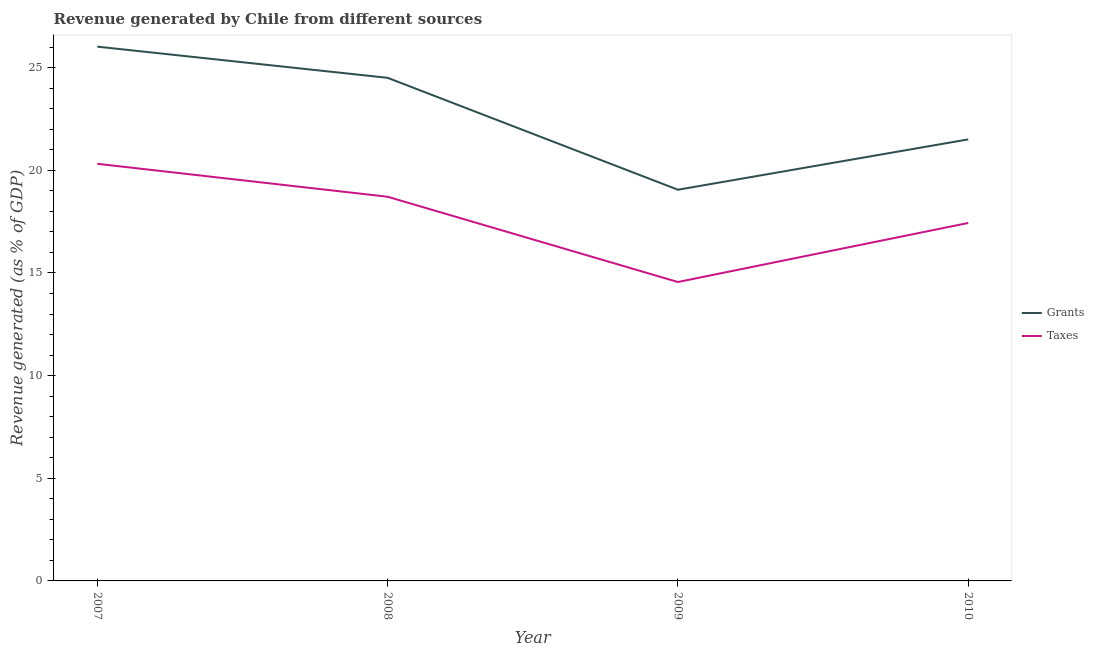Is the number of lines equal to the number of legend labels?
Offer a very short reply. Yes. What is the revenue generated by grants in 2009?
Give a very brief answer. 19.05. Across all years, what is the maximum revenue generated by taxes?
Keep it short and to the point. 20.32. Across all years, what is the minimum revenue generated by taxes?
Your answer should be very brief. 14.56. In which year was the revenue generated by grants maximum?
Your answer should be very brief. 2007. What is the total revenue generated by taxes in the graph?
Your answer should be very brief. 71.03. What is the difference between the revenue generated by grants in 2007 and that in 2008?
Give a very brief answer. 1.52. What is the difference between the revenue generated by taxes in 2010 and the revenue generated by grants in 2008?
Ensure brevity in your answer.  -7.07. What is the average revenue generated by grants per year?
Make the answer very short. 22.77. In the year 2009, what is the difference between the revenue generated by grants and revenue generated by taxes?
Offer a very short reply. 4.5. What is the ratio of the revenue generated by taxes in 2007 to that in 2009?
Give a very brief answer. 1.4. Is the difference between the revenue generated by taxes in 2009 and 2010 greater than the difference between the revenue generated by grants in 2009 and 2010?
Your answer should be very brief. No. What is the difference between the highest and the second highest revenue generated by taxes?
Your answer should be compact. 1.61. What is the difference between the highest and the lowest revenue generated by grants?
Make the answer very short. 6.97. In how many years, is the revenue generated by taxes greater than the average revenue generated by taxes taken over all years?
Give a very brief answer. 2. Is the sum of the revenue generated by taxes in 2007 and 2008 greater than the maximum revenue generated by grants across all years?
Offer a very short reply. Yes. Is the revenue generated by taxes strictly greater than the revenue generated by grants over the years?
Make the answer very short. No. How many lines are there?
Keep it short and to the point. 2. How many years are there in the graph?
Your answer should be compact. 4. What is the difference between two consecutive major ticks on the Y-axis?
Your answer should be very brief. 5. How many legend labels are there?
Give a very brief answer. 2. What is the title of the graph?
Your answer should be compact. Revenue generated by Chile from different sources. What is the label or title of the X-axis?
Provide a succinct answer. Year. What is the label or title of the Y-axis?
Offer a terse response. Revenue generated (as % of GDP). What is the Revenue generated (as % of GDP) in Grants in 2007?
Keep it short and to the point. 26.02. What is the Revenue generated (as % of GDP) of Taxes in 2007?
Provide a succinct answer. 20.32. What is the Revenue generated (as % of GDP) of Grants in 2008?
Offer a very short reply. 24.51. What is the Revenue generated (as % of GDP) of Taxes in 2008?
Provide a short and direct response. 18.71. What is the Revenue generated (as % of GDP) in Grants in 2009?
Your response must be concise. 19.05. What is the Revenue generated (as % of GDP) in Taxes in 2009?
Your answer should be compact. 14.56. What is the Revenue generated (as % of GDP) of Grants in 2010?
Offer a very short reply. 21.51. What is the Revenue generated (as % of GDP) of Taxes in 2010?
Provide a succinct answer. 17.44. Across all years, what is the maximum Revenue generated (as % of GDP) in Grants?
Give a very brief answer. 26.02. Across all years, what is the maximum Revenue generated (as % of GDP) in Taxes?
Your answer should be compact. 20.32. Across all years, what is the minimum Revenue generated (as % of GDP) in Grants?
Your response must be concise. 19.05. Across all years, what is the minimum Revenue generated (as % of GDP) in Taxes?
Provide a succinct answer. 14.56. What is the total Revenue generated (as % of GDP) of Grants in the graph?
Your answer should be compact. 91.09. What is the total Revenue generated (as % of GDP) in Taxes in the graph?
Ensure brevity in your answer.  71.03. What is the difference between the Revenue generated (as % of GDP) in Grants in 2007 and that in 2008?
Your answer should be very brief. 1.52. What is the difference between the Revenue generated (as % of GDP) of Taxes in 2007 and that in 2008?
Your answer should be very brief. 1.61. What is the difference between the Revenue generated (as % of GDP) in Grants in 2007 and that in 2009?
Provide a succinct answer. 6.97. What is the difference between the Revenue generated (as % of GDP) of Taxes in 2007 and that in 2009?
Offer a terse response. 5.76. What is the difference between the Revenue generated (as % of GDP) in Grants in 2007 and that in 2010?
Your response must be concise. 4.52. What is the difference between the Revenue generated (as % of GDP) of Taxes in 2007 and that in 2010?
Give a very brief answer. 2.88. What is the difference between the Revenue generated (as % of GDP) in Grants in 2008 and that in 2009?
Your answer should be very brief. 5.45. What is the difference between the Revenue generated (as % of GDP) in Taxes in 2008 and that in 2009?
Your response must be concise. 4.15. What is the difference between the Revenue generated (as % of GDP) of Grants in 2008 and that in 2010?
Keep it short and to the point. 3. What is the difference between the Revenue generated (as % of GDP) of Taxes in 2008 and that in 2010?
Provide a short and direct response. 1.28. What is the difference between the Revenue generated (as % of GDP) of Grants in 2009 and that in 2010?
Keep it short and to the point. -2.45. What is the difference between the Revenue generated (as % of GDP) of Taxes in 2009 and that in 2010?
Offer a very short reply. -2.88. What is the difference between the Revenue generated (as % of GDP) of Grants in 2007 and the Revenue generated (as % of GDP) of Taxes in 2008?
Your response must be concise. 7.31. What is the difference between the Revenue generated (as % of GDP) in Grants in 2007 and the Revenue generated (as % of GDP) in Taxes in 2009?
Your answer should be compact. 11.46. What is the difference between the Revenue generated (as % of GDP) in Grants in 2007 and the Revenue generated (as % of GDP) in Taxes in 2010?
Offer a terse response. 8.59. What is the difference between the Revenue generated (as % of GDP) in Grants in 2008 and the Revenue generated (as % of GDP) in Taxes in 2009?
Make the answer very short. 9.95. What is the difference between the Revenue generated (as % of GDP) in Grants in 2008 and the Revenue generated (as % of GDP) in Taxes in 2010?
Provide a short and direct response. 7.07. What is the difference between the Revenue generated (as % of GDP) in Grants in 2009 and the Revenue generated (as % of GDP) in Taxes in 2010?
Make the answer very short. 1.62. What is the average Revenue generated (as % of GDP) of Grants per year?
Your response must be concise. 22.77. What is the average Revenue generated (as % of GDP) of Taxes per year?
Provide a succinct answer. 17.76. In the year 2007, what is the difference between the Revenue generated (as % of GDP) in Grants and Revenue generated (as % of GDP) in Taxes?
Provide a succinct answer. 5.71. In the year 2008, what is the difference between the Revenue generated (as % of GDP) in Grants and Revenue generated (as % of GDP) in Taxes?
Provide a short and direct response. 5.79. In the year 2009, what is the difference between the Revenue generated (as % of GDP) of Grants and Revenue generated (as % of GDP) of Taxes?
Provide a short and direct response. 4.5. In the year 2010, what is the difference between the Revenue generated (as % of GDP) in Grants and Revenue generated (as % of GDP) in Taxes?
Give a very brief answer. 4.07. What is the ratio of the Revenue generated (as % of GDP) in Grants in 2007 to that in 2008?
Your answer should be compact. 1.06. What is the ratio of the Revenue generated (as % of GDP) in Taxes in 2007 to that in 2008?
Make the answer very short. 1.09. What is the ratio of the Revenue generated (as % of GDP) of Grants in 2007 to that in 2009?
Provide a short and direct response. 1.37. What is the ratio of the Revenue generated (as % of GDP) of Taxes in 2007 to that in 2009?
Offer a terse response. 1.4. What is the ratio of the Revenue generated (as % of GDP) in Grants in 2007 to that in 2010?
Offer a very short reply. 1.21. What is the ratio of the Revenue generated (as % of GDP) of Taxes in 2007 to that in 2010?
Ensure brevity in your answer.  1.17. What is the ratio of the Revenue generated (as % of GDP) in Grants in 2008 to that in 2009?
Make the answer very short. 1.29. What is the ratio of the Revenue generated (as % of GDP) in Taxes in 2008 to that in 2009?
Give a very brief answer. 1.29. What is the ratio of the Revenue generated (as % of GDP) of Grants in 2008 to that in 2010?
Offer a terse response. 1.14. What is the ratio of the Revenue generated (as % of GDP) of Taxes in 2008 to that in 2010?
Offer a very short reply. 1.07. What is the ratio of the Revenue generated (as % of GDP) in Grants in 2009 to that in 2010?
Ensure brevity in your answer.  0.89. What is the ratio of the Revenue generated (as % of GDP) of Taxes in 2009 to that in 2010?
Provide a short and direct response. 0.83. What is the difference between the highest and the second highest Revenue generated (as % of GDP) in Grants?
Provide a succinct answer. 1.52. What is the difference between the highest and the second highest Revenue generated (as % of GDP) in Taxes?
Your answer should be very brief. 1.61. What is the difference between the highest and the lowest Revenue generated (as % of GDP) of Grants?
Make the answer very short. 6.97. What is the difference between the highest and the lowest Revenue generated (as % of GDP) in Taxes?
Provide a short and direct response. 5.76. 